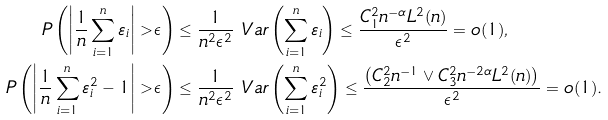Convert formula to latex. <formula><loc_0><loc_0><loc_500><loc_500>P \left ( \left | \frac { 1 } { n } \sum _ { i = 1 } ^ { n } \varepsilon _ { i } \right | > \epsilon \right ) & \leq \frac { 1 } { n ^ { 2 } \epsilon ^ { 2 } } \ V a r \left ( \sum _ { i = 1 } ^ { n } \varepsilon _ { i } \right ) \leq \frac { C _ { 1 } ^ { 2 } n ^ { - \alpha } L ^ { 2 } ( n ) } { \epsilon ^ { 2 } } = o ( 1 ) , \\ P \left ( \left | \frac { 1 } { n } \sum _ { i = 1 } ^ { n } \varepsilon _ { i } ^ { 2 } - 1 \right | > \epsilon \right ) & \leq \frac { 1 } { n ^ { 2 } \epsilon ^ { 2 } } \ V a r \left ( \sum _ { i = 1 } ^ { n } \varepsilon _ { i } ^ { 2 } \right ) \leq \frac { \left ( C _ { 2 } ^ { 2 } n ^ { - 1 } \vee C _ { 3 } ^ { 2 } n ^ { - 2 \alpha } L ^ { 2 } ( n ) \right ) } { \epsilon ^ { 2 } } = o ( 1 ) .</formula> 